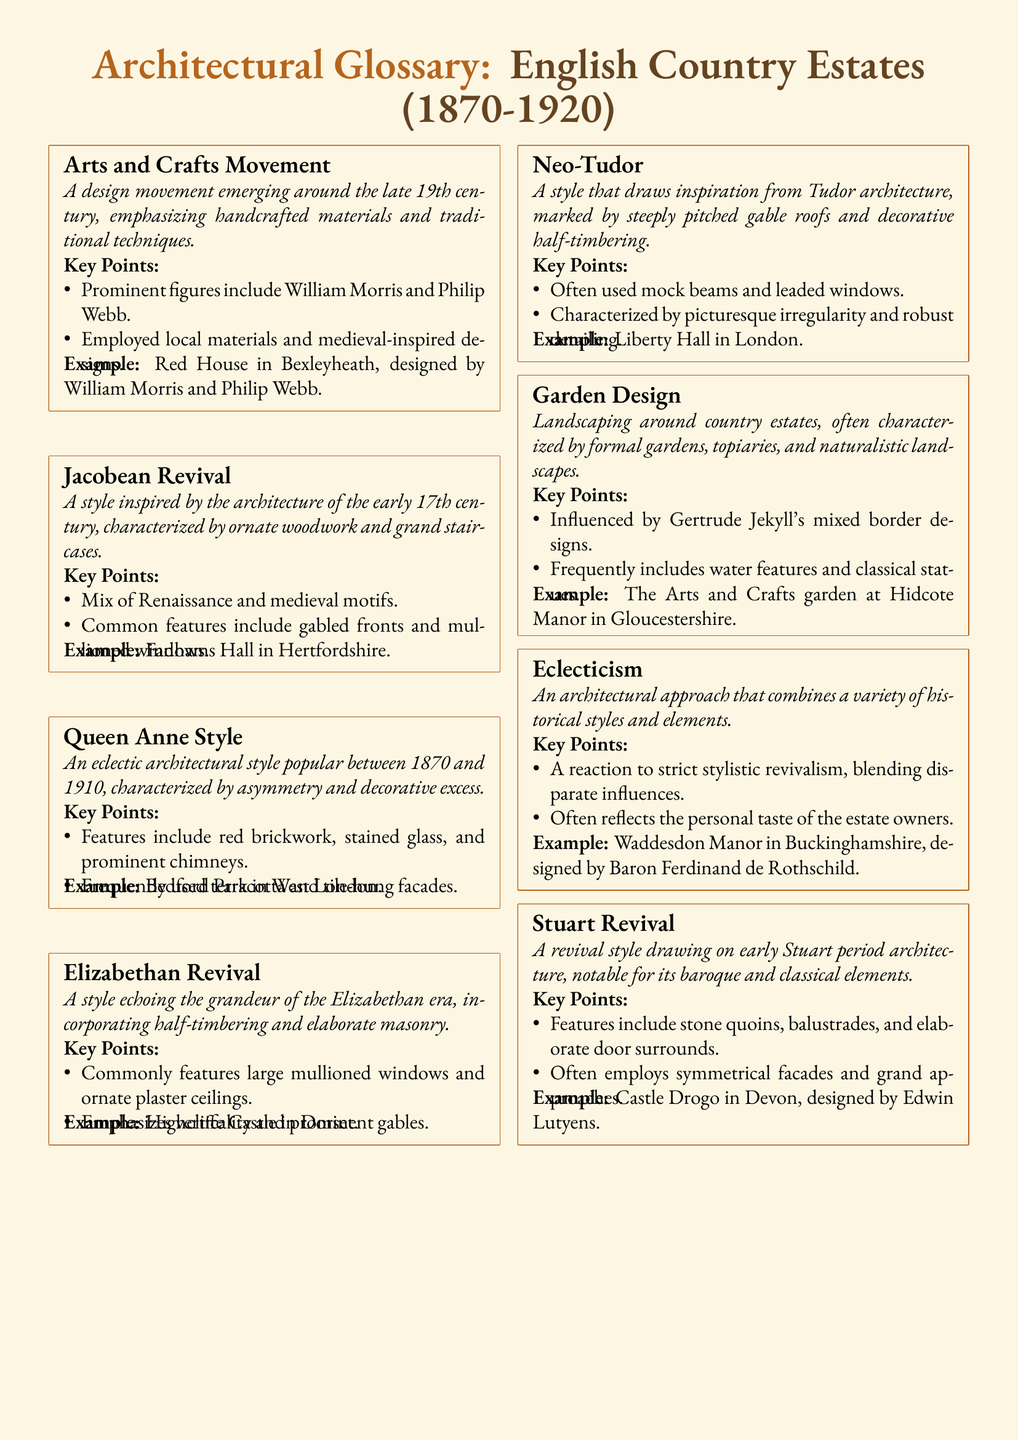What is the design movement that emphasizes handcrafted materials? The glossary entry refers to a design movement emphasizing handcrafted materials and traditional techniques, which is the Arts and Crafts Movement.
Answer: Arts and Crafts Movement Who were prominent figures in the Arts and Crafts Movement? Key figures noted in the glossary entry include individuals who played important roles in the movement, specifically William Morris and Philip Webb.
Answer: William Morris and Philip Webb What architectural style is characterized by ornate woodwork? The glossary specifies a style inspired by early 17th-century architecture known for ornate woodwork, identified as the Jacobean Revival.
Answer: Jacobean Revival Which style incorporates large mullioned windows and ornate plaster ceilings? The document states that the style characterized by this feature, along with verticality and prominent gables, is the Elizabethan Revival.
Answer: Elizabethan Revival What is a common feature of Neo-Tudor architecture? The glossary describes a specific feature of Neo-Tudor style, which prominently includes steeply pitched gable roofs and decorative half-timbering.
Answer: Steeply pitched gable roofs Name an estate designed by Edwin Lutyens. The glossary entry mentions a specific estate designed by Edwin Lutyens, providing an example of the Stuart Revival style.
Answer: Castle Drogo What approach combines a variety of historical styles? The document identifies an architectural approach that combines multiple styles as Eclecticism.
Answer: Eclecticism What influential figure is associated with garden design? The glossary notes a prominent figure in garden design known for mixed border designs, specifically named Gertrude Jekyll.
Answer: Gertrude Jekyll Which estate features the Arts and Crafts garden in Gloucestershire? The glossary entry provides an example of a garden designed in the Arts and Crafts style, located at a specific estate.
Answer: Hidcote Manor 